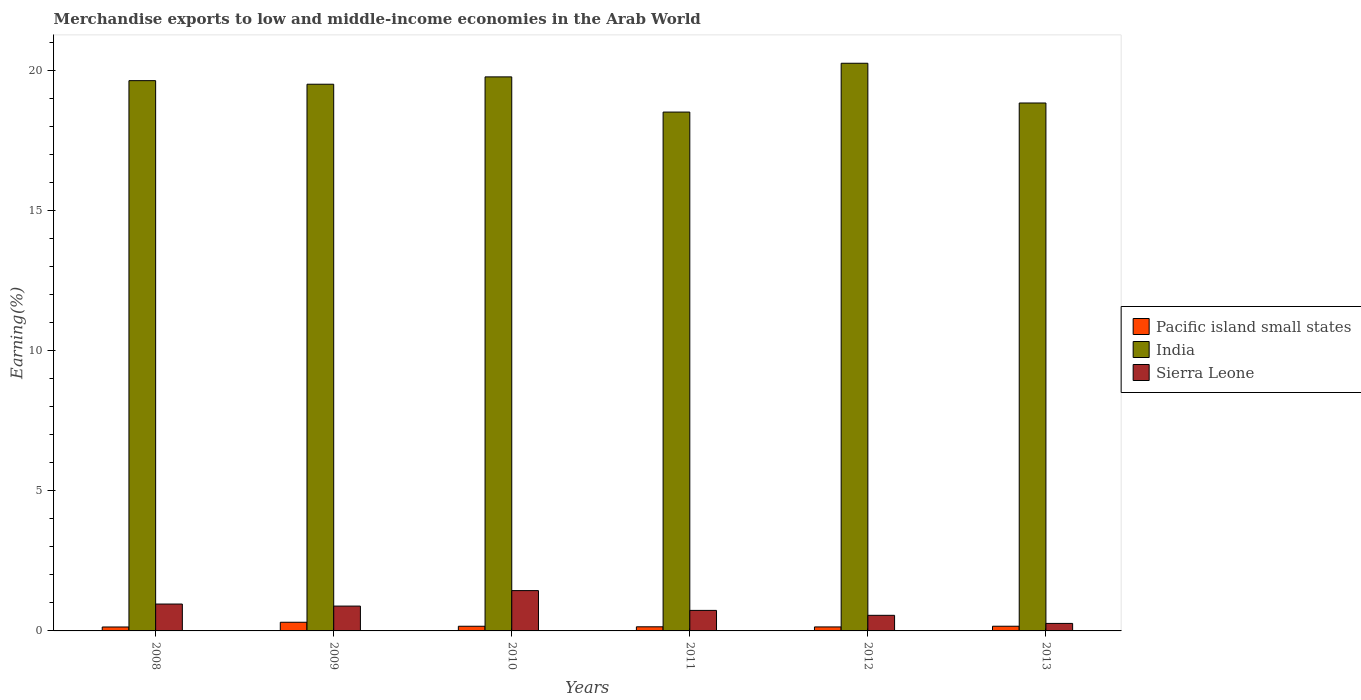How many different coloured bars are there?
Your answer should be compact. 3. Are the number of bars per tick equal to the number of legend labels?
Give a very brief answer. Yes. How many bars are there on the 1st tick from the right?
Provide a succinct answer. 3. What is the label of the 2nd group of bars from the left?
Ensure brevity in your answer.  2009. In how many cases, is the number of bars for a given year not equal to the number of legend labels?
Your answer should be compact. 0. What is the percentage of amount earned from merchandise exports in India in 2010?
Offer a very short reply. 19.76. Across all years, what is the maximum percentage of amount earned from merchandise exports in Pacific island small states?
Your answer should be very brief. 0.31. Across all years, what is the minimum percentage of amount earned from merchandise exports in Pacific island small states?
Offer a very short reply. 0.14. What is the total percentage of amount earned from merchandise exports in Sierra Leone in the graph?
Keep it short and to the point. 4.84. What is the difference between the percentage of amount earned from merchandise exports in Pacific island small states in 2012 and that in 2013?
Offer a very short reply. -0.02. What is the difference between the percentage of amount earned from merchandise exports in Pacific island small states in 2011 and the percentage of amount earned from merchandise exports in India in 2009?
Your answer should be compact. -19.35. What is the average percentage of amount earned from merchandise exports in India per year?
Give a very brief answer. 19.41. In the year 2013, what is the difference between the percentage of amount earned from merchandise exports in India and percentage of amount earned from merchandise exports in Pacific island small states?
Offer a terse response. 18.66. In how many years, is the percentage of amount earned from merchandise exports in Pacific island small states greater than 4 %?
Offer a terse response. 0. What is the ratio of the percentage of amount earned from merchandise exports in India in 2008 to that in 2011?
Provide a short and direct response. 1.06. Is the percentage of amount earned from merchandise exports in Pacific island small states in 2009 less than that in 2012?
Your response must be concise. No. What is the difference between the highest and the second highest percentage of amount earned from merchandise exports in Sierra Leone?
Your response must be concise. 0.48. What is the difference between the highest and the lowest percentage of amount earned from merchandise exports in Sierra Leone?
Your answer should be very brief. 1.17. What does the 1st bar from the left in 2008 represents?
Your response must be concise. Pacific island small states. What does the 3rd bar from the right in 2013 represents?
Give a very brief answer. Pacific island small states. Is it the case that in every year, the sum of the percentage of amount earned from merchandise exports in Pacific island small states and percentage of amount earned from merchandise exports in Sierra Leone is greater than the percentage of amount earned from merchandise exports in India?
Provide a short and direct response. No. How many bars are there?
Make the answer very short. 18. How many years are there in the graph?
Provide a succinct answer. 6. What is the difference between two consecutive major ticks on the Y-axis?
Offer a very short reply. 5. Are the values on the major ticks of Y-axis written in scientific E-notation?
Ensure brevity in your answer.  No. Where does the legend appear in the graph?
Provide a short and direct response. Center right. How many legend labels are there?
Your answer should be compact. 3. What is the title of the graph?
Give a very brief answer. Merchandise exports to low and middle-income economies in the Arab World. What is the label or title of the X-axis?
Offer a very short reply. Years. What is the label or title of the Y-axis?
Make the answer very short. Earning(%). What is the Earning(%) of Pacific island small states in 2008?
Offer a very short reply. 0.14. What is the Earning(%) in India in 2008?
Offer a terse response. 19.63. What is the Earning(%) of Sierra Leone in 2008?
Your response must be concise. 0.96. What is the Earning(%) of Pacific island small states in 2009?
Offer a terse response. 0.31. What is the Earning(%) in India in 2009?
Your answer should be compact. 19.5. What is the Earning(%) of Sierra Leone in 2009?
Offer a terse response. 0.89. What is the Earning(%) in Pacific island small states in 2010?
Your answer should be compact. 0.17. What is the Earning(%) of India in 2010?
Offer a very short reply. 19.76. What is the Earning(%) of Sierra Leone in 2010?
Your response must be concise. 1.44. What is the Earning(%) in Pacific island small states in 2011?
Offer a very short reply. 0.15. What is the Earning(%) of India in 2011?
Offer a terse response. 18.51. What is the Earning(%) of Sierra Leone in 2011?
Ensure brevity in your answer.  0.73. What is the Earning(%) of Pacific island small states in 2012?
Your answer should be compact. 0.14. What is the Earning(%) of India in 2012?
Keep it short and to the point. 20.25. What is the Earning(%) of Sierra Leone in 2012?
Offer a terse response. 0.56. What is the Earning(%) in Pacific island small states in 2013?
Offer a very short reply. 0.17. What is the Earning(%) of India in 2013?
Your answer should be compact. 18.83. What is the Earning(%) of Sierra Leone in 2013?
Your response must be concise. 0.27. Across all years, what is the maximum Earning(%) in Pacific island small states?
Offer a terse response. 0.31. Across all years, what is the maximum Earning(%) in India?
Ensure brevity in your answer.  20.25. Across all years, what is the maximum Earning(%) in Sierra Leone?
Provide a succinct answer. 1.44. Across all years, what is the minimum Earning(%) of Pacific island small states?
Offer a terse response. 0.14. Across all years, what is the minimum Earning(%) of India?
Offer a very short reply. 18.51. Across all years, what is the minimum Earning(%) in Sierra Leone?
Keep it short and to the point. 0.27. What is the total Earning(%) in Pacific island small states in the graph?
Make the answer very short. 1.07. What is the total Earning(%) in India in the graph?
Offer a very short reply. 116.48. What is the total Earning(%) in Sierra Leone in the graph?
Provide a short and direct response. 4.84. What is the difference between the Earning(%) of Pacific island small states in 2008 and that in 2009?
Offer a terse response. -0.17. What is the difference between the Earning(%) of India in 2008 and that in 2009?
Offer a terse response. 0.13. What is the difference between the Earning(%) of Sierra Leone in 2008 and that in 2009?
Your answer should be very brief. 0.07. What is the difference between the Earning(%) in Pacific island small states in 2008 and that in 2010?
Provide a short and direct response. -0.03. What is the difference between the Earning(%) of India in 2008 and that in 2010?
Offer a terse response. -0.13. What is the difference between the Earning(%) in Sierra Leone in 2008 and that in 2010?
Provide a short and direct response. -0.48. What is the difference between the Earning(%) of Pacific island small states in 2008 and that in 2011?
Give a very brief answer. -0.01. What is the difference between the Earning(%) in India in 2008 and that in 2011?
Keep it short and to the point. 1.12. What is the difference between the Earning(%) in Sierra Leone in 2008 and that in 2011?
Offer a terse response. 0.23. What is the difference between the Earning(%) in Pacific island small states in 2008 and that in 2012?
Your answer should be compact. -0. What is the difference between the Earning(%) of India in 2008 and that in 2012?
Offer a very short reply. -0.62. What is the difference between the Earning(%) in Sierra Leone in 2008 and that in 2012?
Your response must be concise. 0.4. What is the difference between the Earning(%) in Pacific island small states in 2008 and that in 2013?
Ensure brevity in your answer.  -0.03. What is the difference between the Earning(%) of India in 2008 and that in 2013?
Make the answer very short. 0.8. What is the difference between the Earning(%) of Sierra Leone in 2008 and that in 2013?
Provide a succinct answer. 0.69. What is the difference between the Earning(%) of Pacific island small states in 2009 and that in 2010?
Provide a succinct answer. 0.14. What is the difference between the Earning(%) of India in 2009 and that in 2010?
Your answer should be compact. -0.26. What is the difference between the Earning(%) of Sierra Leone in 2009 and that in 2010?
Offer a very short reply. -0.55. What is the difference between the Earning(%) in Pacific island small states in 2009 and that in 2011?
Your answer should be very brief. 0.16. What is the difference between the Earning(%) of Sierra Leone in 2009 and that in 2011?
Your response must be concise. 0.15. What is the difference between the Earning(%) in India in 2009 and that in 2012?
Keep it short and to the point. -0.75. What is the difference between the Earning(%) of Sierra Leone in 2009 and that in 2012?
Your response must be concise. 0.33. What is the difference between the Earning(%) of Pacific island small states in 2009 and that in 2013?
Ensure brevity in your answer.  0.14. What is the difference between the Earning(%) of India in 2009 and that in 2013?
Provide a short and direct response. 0.67. What is the difference between the Earning(%) of Sierra Leone in 2009 and that in 2013?
Ensure brevity in your answer.  0.62. What is the difference between the Earning(%) in Pacific island small states in 2010 and that in 2011?
Your response must be concise. 0.02. What is the difference between the Earning(%) of India in 2010 and that in 2011?
Your response must be concise. 1.26. What is the difference between the Earning(%) in Sierra Leone in 2010 and that in 2011?
Your answer should be very brief. 0.71. What is the difference between the Earning(%) in Pacific island small states in 2010 and that in 2012?
Your response must be concise. 0.02. What is the difference between the Earning(%) of India in 2010 and that in 2012?
Offer a very short reply. -0.49. What is the difference between the Earning(%) in Sierra Leone in 2010 and that in 2012?
Provide a succinct answer. 0.88. What is the difference between the Earning(%) in Pacific island small states in 2010 and that in 2013?
Keep it short and to the point. -0. What is the difference between the Earning(%) in India in 2010 and that in 2013?
Make the answer very short. 0.93. What is the difference between the Earning(%) of Sierra Leone in 2010 and that in 2013?
Your response must be concise. 1.17. What is the difference between the Earning(%) of Pacific island small states in 2011 and that in 2012?
Make the answer very short. 0. What is the difference between the Earning(%) in India in 2011 and that in 2012?
Keep it short and to the point. -1.74. What is the difference between the Earning(%) of Sierra Leone in 2011 and that in 2012?
Keep it short and to the point. 0.18. What is the difference between the Earning(%) in Pacific island small states in 2011 and that in 2013?
Your answer should be very brief. -0.02. What is the difference between the Earning(%) of India in 2011 and that in 2013?
Offer a terse response. -0.32. What is the difference between the Earning(%) in Sierra Leone in 2011 and that in 2013?
Your response must be concise. 0.46. What is the difference between the Earning(%) of Pacific island small states in 2012 and that in 2013?
Provide a short and direct response. -0.02. What is the difference between the Earning(%) in India in 2012 and that in 2013?
Your answer should be very brief. 1.42. What is the difference between the Earning(%) of Sierra Leone in 2012 and that in 2013?
Offer a very short reply. 0.29. What is the difference between the Earning(%) of Pacific island small states in 2008 and the Earning(%) of India in 2009?
Provide a short and direct response. -19.36. What is the difference between the Earning(%) of Pacific island small states in 2008 and the Earning(%) of Sierra Leone in 2009?
Make the answer very short. -0.75. What is the difference between the Earning(%) in India in 2008 and the Earning(%) in Sierra Leone in 2009?
Keep it short and to the point. 18.74. What is the difference between the Earning(%) of Pacific island small states in 2008 and the Earning(%) of India in 2010?
Provide a succinct answer. -19.62. What is the difference between the Earning(%) of Pacific island small states in 2008 and the Earning(%) of Sierra Leone in 2010?
Offer a very short reply. -1.3. What is the difference between the Earning(%) of India in 2008 and the Earning(%) of Sierra Leone in 2010?
Your answer should be very brief. 18.19. What is the difference between the Earning(%) in Pacific island small states in 2008 and the Earning(%) in India in 2011?
Offer a terse response. -18.37. What is the difference between the Earning(%) of Pacific island small states in 2008 and the Earning(%) of Sierra Leone in 2011?
Make the answer very short. -0.59. What is the difference between the Earning(%) in India in 2008 and the Earning(%) in Sierra Leone in 2011?
Ensure brevity in your answer.  18.9. What is the difference between the Earning(%) in Pacific island small states in 2008 and the Earning(%) in India in 2012?
Keep it short and to the point. -20.11. What is the difference between the Earning(%) of Pacific island small states in 2008 and the Earning(%) of Sierra Leone in 2012?
Give a very brief answer. -0.42. What is the difference between the Earning(%) in India in 2008 and the Earning(%) in Sierra Leone in 2012?
Provide a short and direct response. 19.07. What is the difference between the Earning(%) in Pacific island small states in 2008 and the Earning(%) in India in 2013?
Offer a very short reply. -18.69. What is the difference between the Earning(%) in Pacific island small states in 2008 and the Earning(%) in Sierra Leone in 2013?
Offer a very short reply. -0.13. What is the difference between the Earning(%) in India in 2008 and the Earning(%) in Sierra Leone in 2013?
Your answer should be compact. 19.36. What is the difference between the Earning(%) of Pacific island small states in 2009 and the Earning(%) of India in 2010?
Your answer should be very brief. -19.45. What is the difference between the Earning(%) in Pacific island small states in 2009 and the Earning(%) in Sierra Leone in 2010?
Make the answer very short. -1.13. What is the difference between the Earning(%) in India in 2009 and the Earning(%) in Sierra Leone in 2010?
Ensure brevity in your answer.  18.06. What is the difference between the Earning(%) in Pacific island small states in 2009 and the Earning(%) in India in 2011?
Provide a short and direct response. -18.2. What is the difference between the Earning(%) in Pacific island small states in 2009 and the Earning(%) in Sierra Leone in 2011?
Keep it short and to the point. -0.42. What is the difference between the Earning(%) of India in 2009 and the Earning(%) of Sierra Leone in 2011?
Provide a succinct answer. 18.77. What is the difference between the Earning(%) of Pacific island small states in 2009 and the Earning(%) of India in 2012?
Your answer should be compact. -19.94. What is the difference between the Earning(%) in Pacific island small states in 2009 and the Earning(%) in Sierra Leone in 2012?
Make the answer very short. -0.25. What is the difference between the Earning(%) of India in 2009 and the Earning(%) of Sierra Leone in 2012?
Offer a very short reply. 18.94. What is the difference between the Earning(%) of Pacific island small states in 2009 and the Earning(%) of India in 2013?
Ensure brevity in your answer.  -18.52. What is the difference between the Earning(%) of Pacific island small states in 2009 and the Earning(%) of Sierra Leone in 2013?
Ensure brevity in your answer.  0.04. What is the difference between the Earning(%) of India in 2009 and the Earning(%) of Sierra Leone in 2013?
Ensure brevity in your answer.  19.23. What is the difference between the Earning(%) in Pacific island small states in 2010 and the Earning(%) in India in 2011?
Provide a succinct answer. -18.34. What is the difference between the Earning(%) of Pacific island small states in 2010 and the Earning(%) of Sierra Leone in 2011?
Make the answer very short. -0.57. What is the difference between the Earning(%) in India in 2010 and the Earning(%) in Sierra Leone in 2011?
Keep it short and to the point. 19.03. What is the difference between the Earning(%) in Pacific island small states in 2010 and the Earning(%) in India in 2012?
Your response must be concise. -20.08. What is the difference between the Earning(%) in Pacific island small states in 2010 and the Earning(%) in Sierra Leone in 2012?
Keep it short and to the point. -0.39. What is the difference between the Earning(%) of India in 2010 and the Earning(%) of Sierra Leone in 2012?
Ensure brevity in your answer.  19.21. What is the difference between the Earning(%) in Pacific island small states in 2010 and the Earning(%) in India in 2013?
Provide a succinct answer. -18.66. What is the difference between the Earning(%) of Pacific island small states in 2010 and the Earning(%) of Sierra Leone in 2013?
Your response must be concise. -0.1. What is the difference between the Earning(%) in India in 2010 and the Earning(%) in Sierra Leone in 2013?
Keep it short and to the point. 19.49. What is the difference between the Earning(%) in Pacific island small states in 2011 and the Earning(%) in India in 2012?
Give a very brief answer. -20.1. What is the difference between the Earning(%) in Pacific island small states in 2011 and the Earning(%) in Sierra Leone in 2012?
Provide a succinct answer. -0.41. What is the difference between the Earning(%) in India in 2011 and the Earning(%) in Sierra Leone in 2012?
Give a very brief answer. 17.95. What is the difference between the Earning(%) in Pacific island small states in 2011 and the Earning(%) in India in 2013?
Provide a short and direct response. -18.68. What is the difference between the Earning(%) in Pacific island small states in 2011 and the Earning(%) in Sierra Leone in 2013?
Your answer should be very brief. -0.12. What is the difference between the Earning(%) in India in 2011 and the Earning(%) in Sierra Leone in 2013?
Make the answer very short. 18.24. What is the difference between the Earning(%) of Pacific island small states in 2012 and the Earning(%) of India in 2013?
Provide a succinct answer. -18.69. What is the difference between the Earning(%) in Pacific island small states in 2012 and the Earning(%) in Sierra Leone in 2013?
Your answer should be compact. -0.13. What is the difference between the Earning(%) of India in 2012 and the Earning(%) of Sierra Leone in 2013?
Give a very brief answer. 19.98. What is the average Earning(%) in Pacific island small states per year?
Keep it short and to the point. 0.18. What is the average Earning(%) in India per year?
Offer a very short reply. 19.41. What is the average Earning(%) of Sierra Leone per year?
Provide a succinct answer. 0.81. In the year 2008, what is the difference between the Earning(%) of Pacific island small states and Earning(%) of India?
Ensure brevity in your answer.  -19.49. In the year 2008, what is the difference between the Earning(%) of Pacific island small states and Earning(%) of Sierra Leone?
Offer a terse response. -0.82. In the year 2008, what is the difference between the Earning(%) of India and Earning(%) of Sierra Leone?
Your response must be concise. 18.67. In the year 2009, what is the difference between the Earning(%) in Pacific island small states and Earning(%) in India?
Your answer should be compact. -19.19. In the year 2009, what is the difference between the Earning(%) of Pacific island small states and Earning(%) of Sierra Leone?
Provide a succinct answer. -0.58. In the year 2009, what is the difference between the Earning(%) of India and Earning(%) of Sierra Leone?
Provide a succinct answer. 18.61. In the year 2010, what is the difference between the Earning(%) of Pacific island small states and Earning(%) of India?
Your response must be concise. -19.6. In the year 2010, what is the difference between the Earning(%) of Pacific island small states and Earning(%) of Sierra Leone?
Offer a terse response. -1.27. In the year 2010, what is the difference between the Earning(%) of India and Earning(%) of Sierra Leone?
Ensure brevity in your answer.  18.32. In the year 2011, what is the difference between the Earning(%) in Pacific island small states and Earning(%) in India?
Offer a terse response. -18.36. In the year 2011, what is the difference between the Earning(%) of Pacific island small states and Earning(%) of Sierra Leone?
Your response must be concise. -0.59. In the year 2011, what is the difference between the Earning(%) in India and Earning(%) in Sierra Leone?
Offer a very short reply. 17.78. In the year 2012, what is the difference between the Earning(%) in Pacific island small states and Earning(%) in India?
Offer a terse response. -20.11. In the year 2012, what is the difference between the Earning(%) of Pacific island small states and Earning(%) of Sierra Leone?
Provide a succinct answer. -0.41. In the year 2012, what is the difference between the Earning(%) of India and Earning(%) of Sierra Leone?
Ensure brevity in your answer.  19.69. In the year 2013, what is the difference between the Earning(%) of Pacific island small states and Earning(%) of India?
Make the answer very short. -18.66. In the year 2013, what is the difference between the Earning(%) in Pacific island small states and Earning(%) in Sierra Leone?
Your response must be concise. -0.1. In the year 2013, what is the difference between the Earning(%) of India and Earning(%) of Sierra Leone?
Provide a short and direct response. 18.56. What is the ratio of the Earning(%) of Pacific island small states in 2008 to that in 2009?
Your response must be concise. 0.45. What is the ratio of the Earning(%) in India in 2008 to that in 2009?
Your answer should be compact. 1.01. What is the ratio of the Earning(%) of Sierra Leone in 2008 to that in 2009?
Provide a short and direct response. 1.08. What is the ratio of the Earning(%) in Pacific island small states in 2008 to that in 2010?
Your response must be concise. 0.84. What is the ratio of the Earning(%) of India in 2008 to that in 2010?
Your answer should be very brief. 0.99. What is the ratio of the Earning(%) in Sierra Leone in 2008 to that in 2010?
Ensure brevity in your answer.  0.67. What is the ratio of the Earning(%) in Pacific island small states in 2008 to that in 2011?
Your answer should be compact. 0.96. What is the ratio of the Earning(%) of India in 2008 to that in 2011?
Your answer should be very brief. 1.06. What is the ratio of the Earning(%) in Sierra Leone in 2008 to that in 2011?
Offer a terse response. 1.31. What is the ratio of the Earning(%) in Pacific island small states in 2008 to that in 2012?
Offer a terse response. 0.99. What is the ratio of the Earning(%) of India in 2008 to that in 2012?
Your answer should be very brief. 0.97. What is the ratio of the Earning(%) in Sierra Leone in 2008 to that in 2012?
Keep it short and to the point. 1.72. What is the ratio of the Earning(%) of Pacific island small states in 2008 to that in 2013?
Ensure brevity in your answer.  0.84. What is the ratio of the Earning(%) in India in 2008 to that in 2013?
Provide a short and direct response. 1.04. What is the ratio of the Earning(%) of Sierra Leone in 2008 to that in 2013?
Provide a short and direct response. 3.58. What is the ratio of the Earning(%) in Pacific island small states in 2009 to that in 2010?
Keep it short and to the point. 1.86. What is the ratio of the Earning(%) of India in 2009 to that in 2010?
Your response must be concise. 0.99. What is the ratio of the Earning(%) in Sierra Leone in 2009 to that in 2010?
Your response must be concise. 0.62. What is the ratio of the Earning(%) in Pacific island small states in 2009 to that in 2011?
Keep it short and to the point. 2.1. What is the ratio of the Earning(%) in India in 2009 to that in 2011?
Offer a very short reply. 1.05. What is the ratio of the Earning(%) in Sierra Leone in 2009 to that in 2011?
Your response must be concise. 1.21. What is the ratio of the Earning(%) in Pacific island small states in 2009 to that in 2012?
Provide a succinct answer. 2.17. What is the ratio of the Earning(%) of India in 2009 to that in 2012?
Your answer should be very brief. 0.96. What is the ratio of the Earning(%) of Sierra Leone in 2009 to that in 2012?
Offer a very short reply. 1.59. What is the ratio of the Earning(%) in Pacific island small states in 2009 to that in 2013?
Make the answer very short. 1.85. What is the ratio of the Earning(%) in India in 2009 to that in 2013?
Your answer should be compact. 1.04. What is the ratio of the Earning(%) of Sierra Leone in 2009 to that in 2013?
Give a very brief answer. 3.3. What is the ratio of the Earning(%) in Pacific island small states in 2010 to that in 2011?
Provide a succinct answer. 1.13. What is the ratio of the Earning(%) of India in 2010 to that in 2011?
Give a very brief answer. 1.07. What is the ratio of the Earning(%) of Sierra Leone in 2010 to that in 2011?
Provide a short and direct response. 1.96. What is the ratio of the Earning(%) in Pacific island small states in 2010 to that in 2012?
Provide a short and direct response. 1.17. What is the ratio of the Earning(%) in Sierra Leone in 2010 to that in 2012?
Offer a very short reply. 2.58. What is the ratio of the Earning(%) in Pacific island small states in 2010 to that in 2013?
Offer a terse response. 0.99. What is the ratio of the Earning(%) of India in 2010 to that in 2013?
Give a very brief answer. 1.05. What is the ratio of the Earning(%) of Sierra Leone in 2010 to that in 2013?
Your response must be concise. 5.37. What is the ratio of the Earning(%) in Pacific island small states in 2011 to that in 2012?
Your answer should be compact. 1.03. What is the ratio of the Earning(%) of India in 2011 to that in 2012?
Your answer should be very brief. 0.91. What is the ratio of the Earning(%) in Sierra Leone in 2011 to that in 2012?
Your response must be concise. 1.32. What is the ratio of the Earning(%) in Pacific island small states in 2011 to that in 2013?
Offer a very short reply. 0.88. What is the ratio of the Earning(%) of India in 2011 to that in 2013?
Your answer should be very brief. 0.98. What is the ratio of the Earning(%) in Sierra Leone in 2011 to that in 2013?
Provide a short and direct response. 2.73. What is the ratio of the Earning(%) in Pacific island small states in 2012 to that in 2013?
Your response must be concise. 0.85. What is the ratio of the Earning(%) in India in 2012 to that in 2013?
Your answer should be compact. 1.08. What is the ratio of the Earning(%) of Sierra Leone in 2012 to that in 2013?
Make the answer very short. 2.08. What is the difference between the highest and the second highest Earning(%) in Pacific island small states?
Provide a short and direct response. 0.14. What is the difference between the highest and the second highest Earning(%) in India?
Keep it short and to the point. 0.49. What is the difference between the highest and the second highest Earning(%) of Sierra Leone?
Your answer should be very brief. 0.48. What is the difference between the highest and the lowest Earning(%) of Pacific island small states?
Provide a succinct answer. 0.17. What is the difference between the highest and the lowest Earning(%) in India?
Offer a very short reply. 1.74. What is the difference between the highest and the lowest Earning(%) in Sierra Leone?
Your answer should be compact. 1.17. 